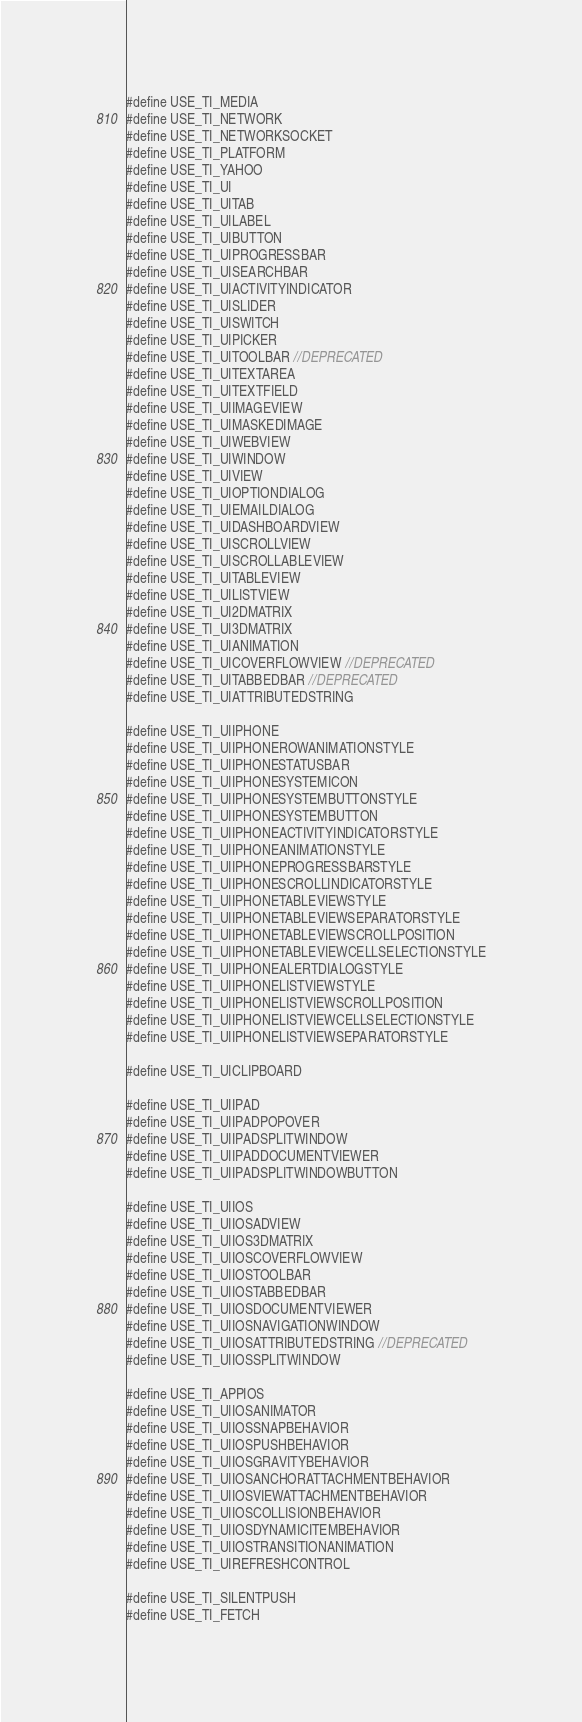Convert code to text. <code><loc_0><loc_0><loc_500><loc_500><_C_>#define USE_TI_MEDIA
#define USE_TI_NETWORK
#define USE_TI_NETWORKSOCKET
#define USE_TI_PLATFORM
#define USE_TI_YAHOO
#define USE_TI_UI
#define USE_TI_UITAB
#define USE_TI_UILABEL
#define USE_TI_UIBUTTON
#define USE_TI_UIPROGRESSBAR
#define USE_TI_UISEARCHBAR
#define USE_TI_UIACTIVITYINDICATOR
#define USE_TI_UISLIDER
#define USE_TI_UISWITCH
#define USE_TI_UIPICKER
#define USE_TI_UITOOLBAR //DEPRECATED
#define USE_TI_UITEXTAREA
#define USE_TI_UITEXTFIELD
#define USE_TI_UIIMAGEVIEW
#define USE_TI_UIMASKEDIMAGE
#define USE_TI_UIWEBVIEW
#define USE_TI_UIWINDOW
#define USE_TI_UIVIEW
#define USE_TI_UIOPTIONDIALOG
#define USE_TI_UIEMAILDIALOG
#define USE_TI_UIDASHBOARDVIEW
#define USE_TI_UISCROLLVIEW
#define USE_TI_UISCROLLABLEVIEW
#define USE_TI_UITABLEVIEW
#define USE_TI_UILISTVIEW
#define USE_TI_UI2DMATRIX
#define USE_TI_UI3DMATRIX
#define USE_TI_UIANIMATION
#define USE_TI_UICOVERFLOWVIEW //DEPRECATED 
#define USE_TI_UITABBEDBAR //DEPRECATED
#define USE_TI_UIATTRIBUTEDSTRING

#define USE_TI_UIIPHONE
#define USE_TI_UIIPHONEROWANIMATIONSTYLE
#define USE_TI_UIIPHONESTATUSBAR
#define USE_TI_UIIPHONESYSTEMICON
#define USE_TI_UIIPHONESYSTEMBUTTONSTYLE
#define USE_TI_UIIPHONESYSTEMBUTTON
#define USE_TI_UIIPHONEACTIVITYINDICATORSTYLE
#define USE_TI_UIIPHONEANIMATIONSTYLE
#define USE_TI_UIIPHONEPROGRESSBARSTYLE
#define USE_TI_UIIPHONESCROLLINDICATORSTYLE
#define USE_TI_UIIPHONETABLEVIEWSTYLE
#define USE_TI_UIIPHONETABLEVIEWSEPARATORSTYLE
#define USE_TI_UIIPHONETABLEVIEWSCROLLPOSITION
#define USE_TI_UIIPHONETABLEVIEWCELLSELECTIONSTYLE
#define USE_TI_UIIPHONEALERTDIALOGSTYLE
#define USE_TI_UIIPHONELISTVIEWSTYLE
#define USE_TI_UIIPHONELISTVIEWSCROLLPOSITION
#define USE_TI_UIIPHONELISTVIEWCELLSELECTIONSTYLE
#define USE_TI_UIIPHONELISTVIEWSEPARATORSTYLE

#define USE_TI_UICLIPBOARD

#define USE_TI_UIIPAD
#define USE_TI_UIIPADPOPOVER
#define USE_TI_UIIPADSPLITWINDOW
#define USE_TI_UIIPADDOCUMENTVIEWER
#define USE_TI_UIIPADSPLITWINDOWBUTTON

#define USE_TI_UIIOS
#define USE_TI_UIIOSADVIEW
#define USE_TI_UIIOS3DMATRIX
#define USE_TI_UIIOSCOVERFLOWVIEW
#define USE_TI_UIIOSTOOLBAR
#define USE_TI_UIIOSTABBEDBAR
#define USE_TI_UIIOSDOCUMENTVIEWER
#define USE_TI_UIIOSNAVIGATIONWINDOW
#define USE_TI_UIIOSATTRIBUTEDSTRING //DEPRECATED
#define USE_TI_UIIOSSPLITWINDOW

#define USE_TI_APPIOS
#define USE_TI_UIIOSANIMATOR
#define USE_TI_UIIOSSNAPBEHAVIOR
#define USE_TI_UIIOSPUSHBEHAVIOR
#define USE_TI_UIIOSGRAVITYBEHAVIOR
#define USE_TI_UIIOSANCHORATTACHMENTBEHAVIOR
#define USE_TI_UIIOSVIEWATTACHMENTBEHAVIOR
#define USE_TI_UIIOSCOLLISIONBEHAVIOR
#define USE_TI_UIIOSDYNAMICITEMBEHAVIOR
#define USE_TI_UIIOSTRANSITIONANIMATION
#define USE_TI_UIREFRESHCONTROL

#define USE_TI_SILENTPUSH
#define USE_TI_FETCH
</code> 